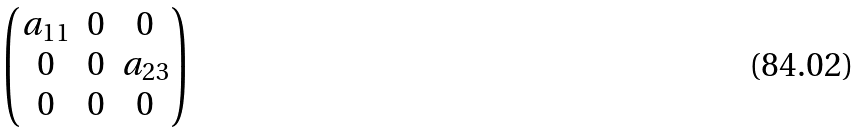Convert formula to latex. <formula><loc_0><loc_0><loc_500><loc_500>\begin{pmatrix} a _ { 1 1 } & 0 & 0 \\ 0 & 0 & a _ { 2 3 } \\ 0 & 0 & 0 \\ \end{pmatrix}</formula> 